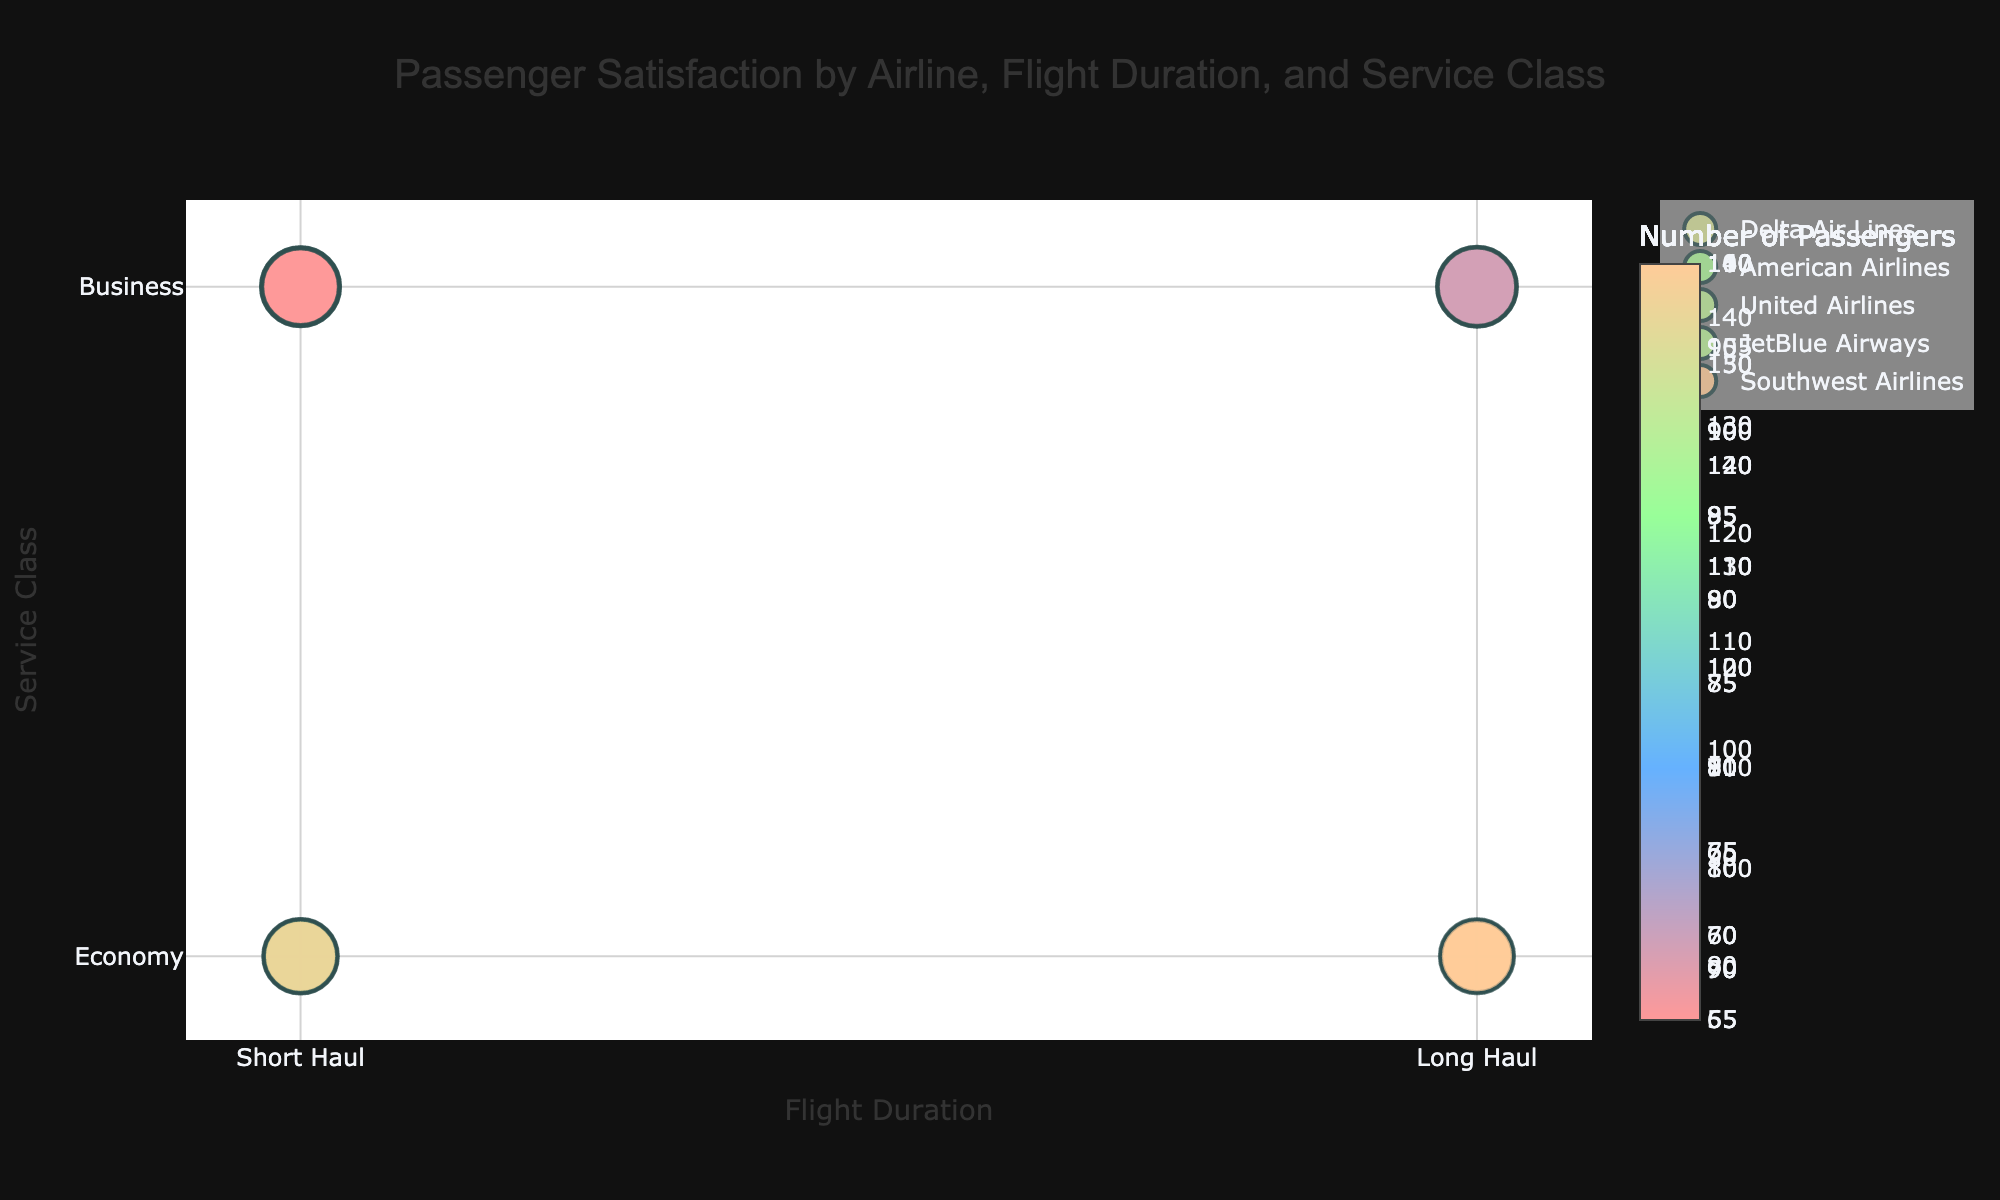How many airlines are represented in the chart? You can count the number of unique names listed in the legend on the right. Each name corresponds to a different airline.
Answer: 5 Which airline has the highest passenger satisfaction score for long haul, business class? To find this, look at the long haul and business class section, then identify the highest bubble size. The airline associated with that bubble is the one with the highest score.
Answer: Delta Air Lines What is the size of the bubble for Delta Air Lines in short haul, economy class? Locate the bubbles for Delta Air Lines, focus on short haul and economy class, and observe the bubble size. The size is determined by the passenger satisfaction score. The text by hovering or size can guide you.
Answer: 80 Which service class for United Airlines has a higher satisfaction score, short haul business class or long haul business class? Compare the bubble sizes for United Airlines in short haul business class and long haul business class. The larger bubble will indicate the higher score.
Answer: Long haul business class Which service class has the smallest bubble for JetBlue Airways? Look at the bubbles corresponding to JetBlue Airways and compare their sizes across the service classes. The smallest bubble will indicate the lowest satisfaction score.
Answer: Short haul business class Between Delta Air Lines and Southwest Airlines, which has more passengers for short haul business class? Check for the bubble size and color intensity for Delta Air Lines and Southwest Airlines under short haul business class. The bubble with the darker color and larger value indicates more passengers.
Answer: Delta Air Lines How does the average passenger satisfaction score for economy class compare between Delta Air Lines and American Airlines across both flight durations? Calculate the average satisfaction score for Delta Air Lines (short haul and long haul for economy) and compare it to American Airlines. Average each and then compare. Delta: (80+78)/2 = 79; American: (75+75)/2 = 75.
Answer: Delta has a higher average score Which airline has the darkest colored bubble in short haul economy class, and what does it signify? Identify the darkest colored bubble among the airlines in short haul economy class. The darkest color represents the highest number of passengers.
Answer: Delta Air Lines Does JetBlue Airways have any flight class where passenger satisfaction is above 90? Observe the size of the bubbles for JetBlue Airways across all classes. Bubble size directly corresponds to satisfaction score.
Answer: No What can be inferred about overall passenger satisfaction for business class flights compared to economy class across airlines and flight durations? Generally, compare the average size of the bubbles representing business class and economy class for all airlines. Business class bubbles are significantly larger, suggesting higher satisfaction scores.
Answer: Business class has higher satisfaction 